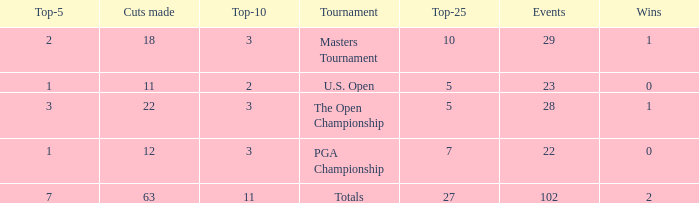How many top 10s connected with 3 top 5s and below 22 cuts made? None. 